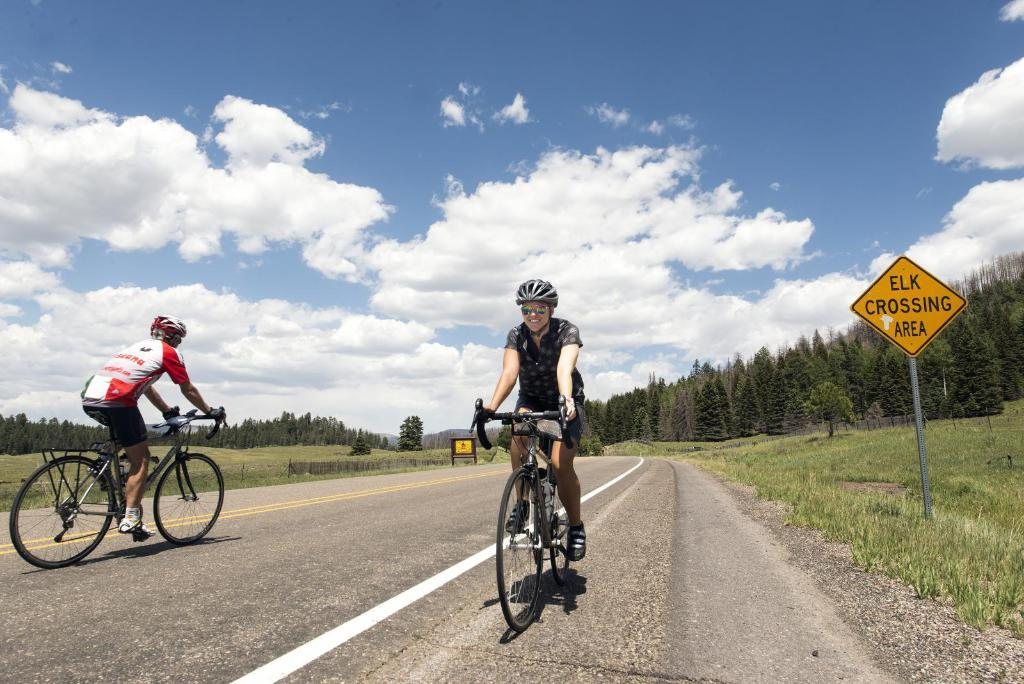How many people are in the image? There are two people in the image. What are the people wearing on their heads? The people are wearing helmets. What activity are the people engaged in? The people are riding bicycles. What type of terrain can be seen in the image? There is grass in the image. What is the purpose of the sign board in the image? The purpose of the sign board is not specified in the image. What type of vegetation is present in the image? There are trees in the image. What is visible in the sky in the image? The sky is visible in the image, and there are clouds present. How many watches can be seen on the people's wrists in the image? There is no mention of watches in the image, so it cannot be determined how many are present. 